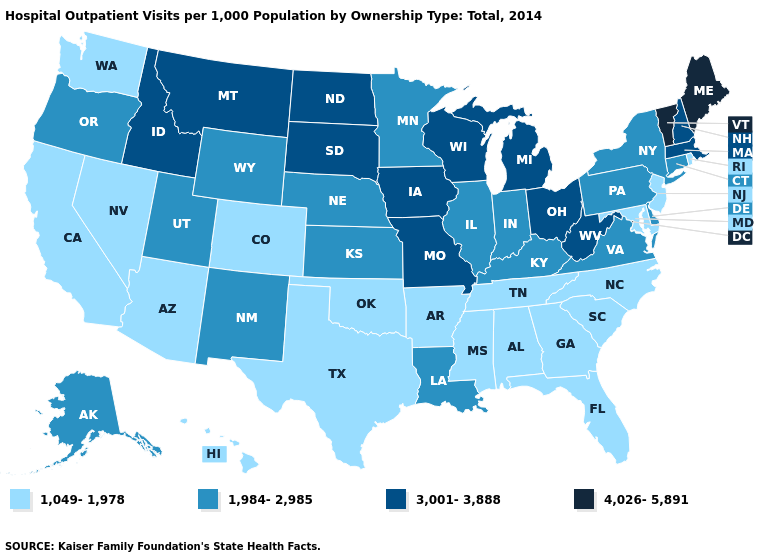What is the value of Delaware?
Short answer required. 1,984-2,985. Does Louisiana have the highest value in the South?
Write a very short answer. No. Name the states that have a value in the range 3,001-3,888?
Answer briefly. Idaho, Iowa, Massachusetts, Michigan, Missouri, Montana, New Hampshire, North Dakota, Ohio, South Dakota, West Virginia, Wisconsin. What is the value of Ohio?
Be succinct. 3,001-3,888. What is the lowest value in the South?
Short answer required. 1,049-1,978. What is the value of North Carolina?
Short answer required. 1,049-1,978. What is the lowest value in states that border Wyoming?
Concise answer only. 1,049-1,978. Does Illinois have the same value as Kentucky?
Concise answer only. Yes. Does Arkansas have a lower value than Arizona?
Answer briefly. No. Which states have the highest value in the USA?
Be succinct. Maine, Vermont. What is the value of Iowa?
Concise answer only. 3,001-3,888. What is the lowest value in the South?
Write a very short answer. 1,049-1,978. What is the value of New Hampshire?
Short answer required. 3,001-3,888. Name the states that have a value in the range 1,984-2,985?
Be succinct. Alaska, Connecticut, Delaware, Illinois, Indiana, Kansas, Kentucky, Louisiana, Minnesota, Nebraska, New Mexico, New York, Oregon, Pennsylvania, Utah, Virginia, Wyoming. Name the states that have a value in the range 1,049-1,978?
Answer briefly. Alabama, Arizona, Arkansas, California, Colorado, Florida, Georgia, Hawaii, Maryland, Mississippi, Nevada, New Jersey, North Carolina, Oklahoma, Rhode Island, South Carolina, Tennessee, Texas, Washington. 